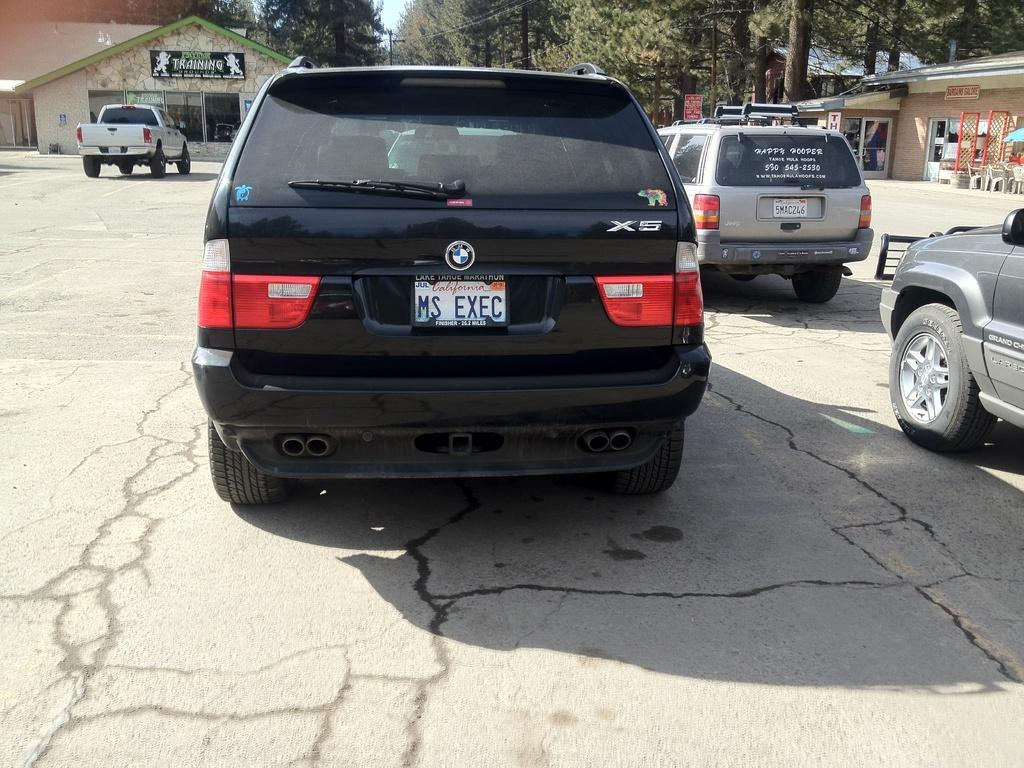<image>
Present a compact description of the photo's key features. A BMW SUV with license plate MS EXEC. 